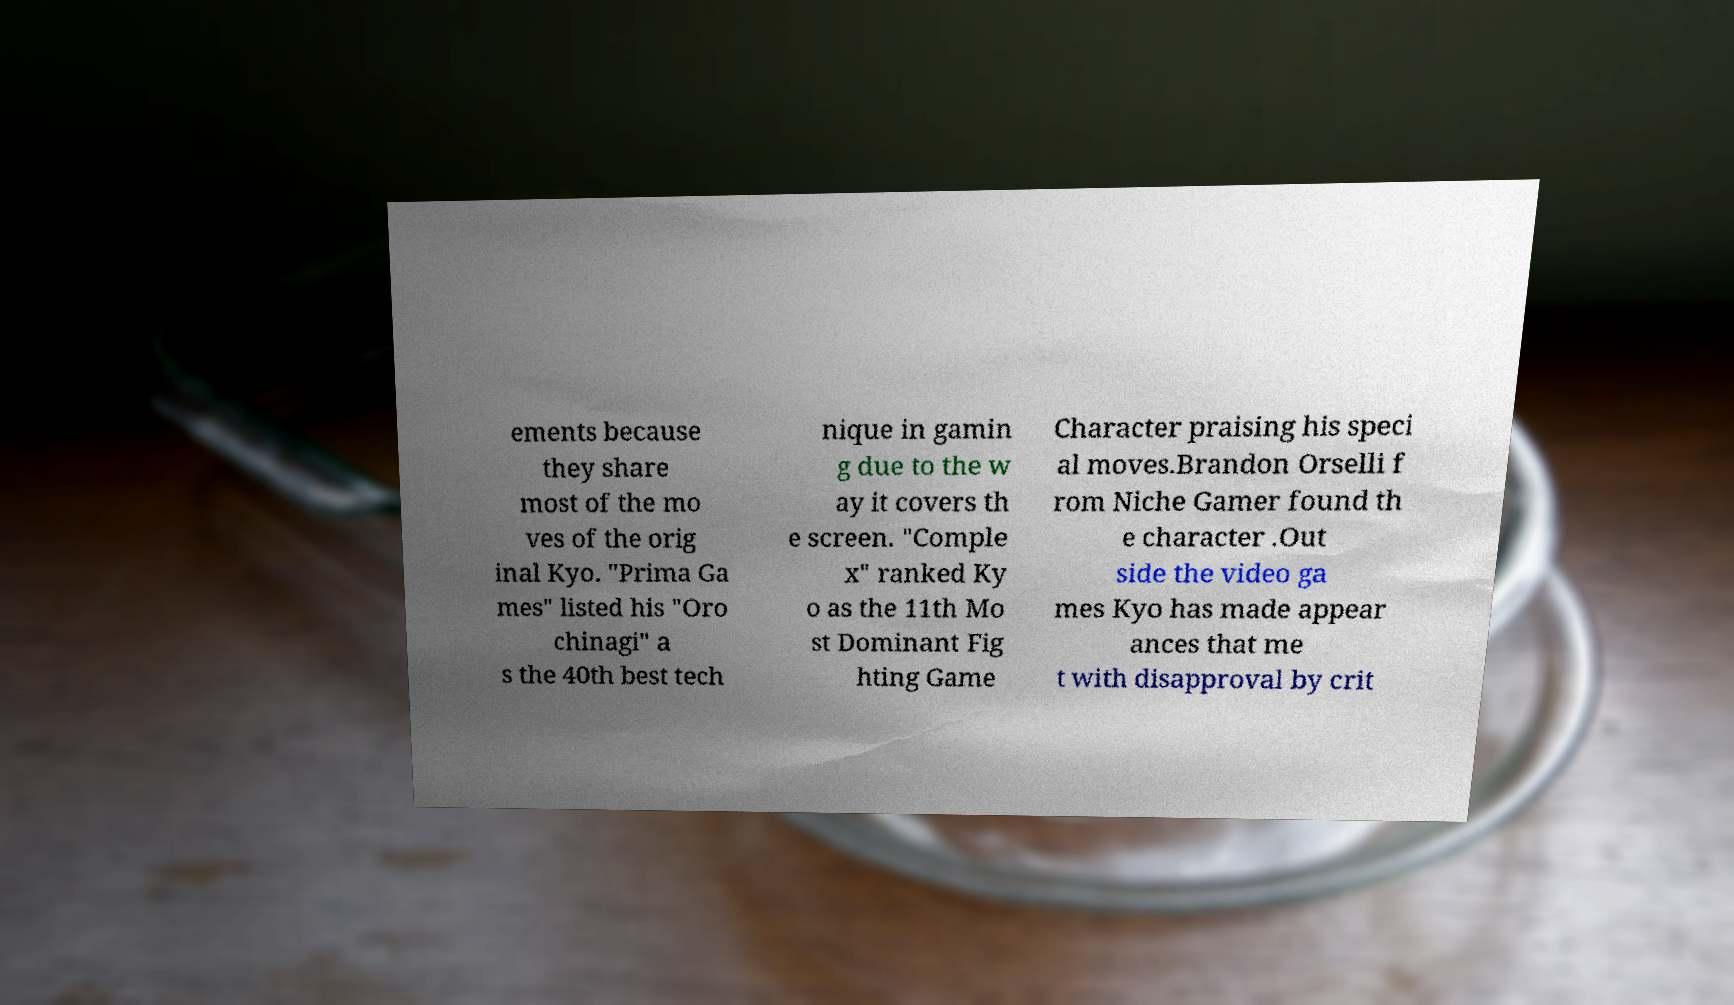What messages or text are displayed in this image? I need them in a readable, typed format. ements because they share most of the mo ves of the orig inal Kyo. "Prima Ga mes" listed his "Oro chinagi" a s the 40th best tech nique in gamin g due to the w ay it covers th e screen. "Comple x" ranked Ky o as the 11th Mo st Dominant Fig hting Game Character praising his speci al moves.Brandon Orselli f rom Niche Gamer found th e character .Out side the video ga mes Kyo has made appear ances that me t with disapproval by crit 